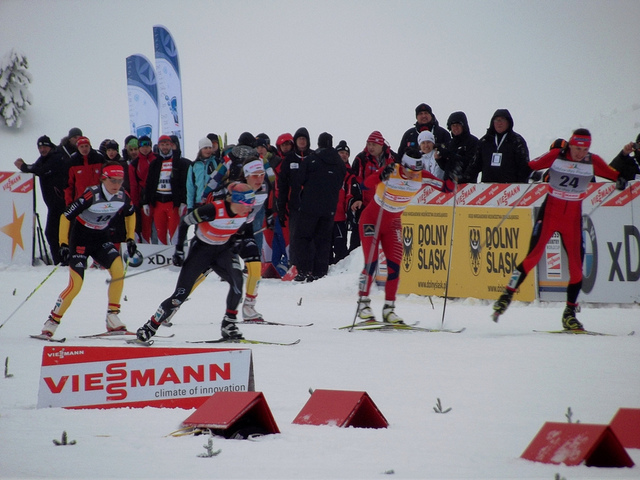What might be the importance of the banners and flags along the race track? The banners and flags represent both the sponsors supporting the event and likely the different nations participating. They add a festive and competitive atmosphere, while also providing waypoints for spectators and racers. 